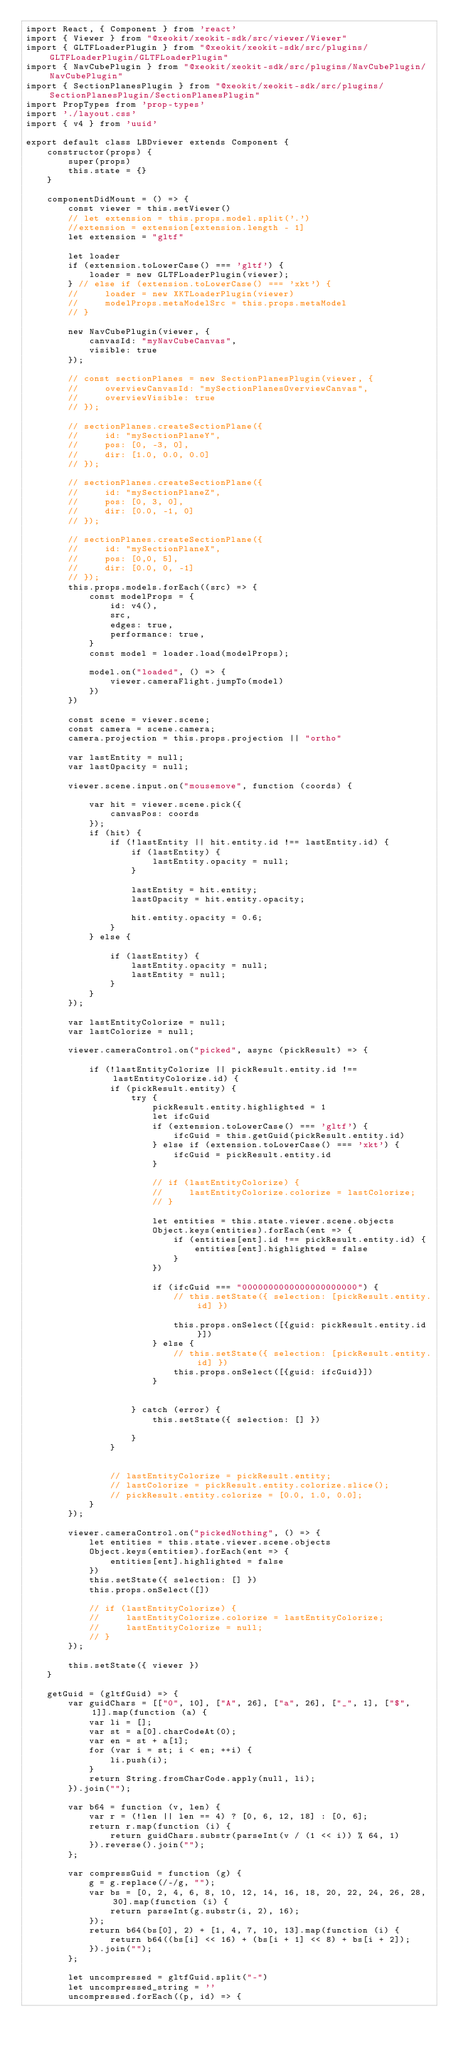<code> <loc_0><loc_0><loc_500><loc_500><_JavaScript_>import React, { Component } from 'react'
import { Viewer } from "@xeokit/xeokit-sdk/src/viewer/Viewer"
import { GLTFLoaderPlugin } from "@xeokit/xeokit-sdk/src/plugins/GLTFLoaderPlugin/GLTFLoaderPlugin"
import { NavCubePlugin } from "@xeokit/xeokit-sdk/src/plugins/NavCubePlugin/NavCubePlugin"
import { SectionPlanesPlugin } from "@xeokit/xeokit-sdk/src/plugins/SectionPlanesPlugin/SectionPlanesPlugin"
import PropTypes from 'prop-types'
import './layout.css'
import { v4 } from 'uuid'

export default class LBDviewer extends Component {
    constructor(props) {
        super(props)
        this.state = {}
    }

    componentDidMount = () => {
        const viewer = this.setViewer()
        // let extension = this.props.model.split('.')
        //extension = extension[extension.length - 1]
        let extension = "gltf"

        let loader
        if (extension.toLowerCase() === 'gltf') {
            loader = new GLTFLoaderPlugin(viewer);
        } // else if (extension.toLowerCase() === 'xkt') {
        //     loader = new XKTLoaderPlugin(viewer)
        //     modelProps.metaModelSrc = this.props.metaModel
        // }

        new NavCubePlugin(viewer, {
            canvasId: "myNavCubeCanvas",
            visible: true
        });

        // const sectionPlanes = new SectionPlanesPlugin(viewer, {
        //     overviewCanvasId: "mySectionPlanesOverviewCanvas",
        //     overviewVisible: true
        // });

        // sectionPlanes.createSectionPlane({
        //     id: "mySectionPlaneY",
        //     pos: [0, -3, 0],
        //     dir: [1.0, 0.0, 0.0]
        // });

        // sectionPlanes.createSectionPlane({
        //     id: "mySectionPlaneZ",
        //     pos: [0, 3, 0],
        //     dir: [0.0, -1, 0]
        // });

        // sectionPlanes.createSectionPlane({
        //     id: "mySectionPlaneX",
        //     pos: [0,0, 5],
        //     dir: [0.0, 0, -1]
        // });
        this.props.models.forEach((src) => {
            const modelProps = {
                id: v4(),
                src,
                edges: true,
                performance: true,
            }
            const model = loader.load(modelProps);

            model.on("loaded", () => {
                viewer.cameraFlight.jumpTo(model)
            })
        })

        const scene = viewer.scene;
        const camera = scene.camera;
        camera.projection = this.props.projection || "ortho"

        var lastEntity = null;
        var lastOpacity = null;

        viewer.scene.input.on("mousemove", function (coords) {

            var hit = viewer.scene.pick({
                canvasPos: coords
            });
            if (hit) {
                if (!lastEntity || hit.entity.id !== lastEntity.id) {
                    if (lastEntity) {
                        lastEntity.opacity = null;
                    }

                    lastEntity = hit.entity;
                    lastOpacity = hit.entity.opacity;

                    hit.entity.opacity = 0.6;
                }
            } else {

                if (lastEntity) {
                    lastEntity.opacity = null;
                    lastEntity = null;
                }
            }
        });

        var lastEntityColorize = null;
        var lastColorize = null;

        viewer.cameraControl.on("picked", async (pickResult) => {

            if (!lastEntityColorize || pickResult.entity.id !== lastEntityColorize.id) {
                if (pickResult.entity) {
                    try {
                        pickResult.entity.highlighted = 1
                        let ifcGuid
                        if (extension.toLowerCase() === 'gltf') {
                            ifcGuid = this.getGuid(pickResult.entity.id)
                        } else if (extension.toLowerCase() === 'xkt') {
                            ifcGuid = pickResult.entity.id
                        }

                        // if (lastEntityColorize) {
                        //     lastEntityColorize.colorize = lastColorize;
                        // }

                        let entities = this.state.viewer.scene.objects
                        Object.keys(entities).forEach(ent => {
                            if (entities[ent].id !== pickResult.entity.id) {
                                entities[ent].highlighted = false
                            }
                        })

                        if (ifcGuid === "0000000000000000000000") {
                            // this.setState({ selection: [pickResult.entity.id] })

                            this.props.onSelect([{guid: pickResult.entity.id}])
                        } else {
                            // this.setState({ selection: [pickResult.entity.id] })
                            this.props.onSelect([{guid: ifcGuid}])
                        }


                    } catch (error) {
                        this.setState({ selection: [] })

                    }
                }


                // lastEntityColorize = pickResult.entity;
                // lastColorize = pickResult.entity.colorize.slice();
                // pickResult.entity.colorize = [0.0, 1.0, 0.0];
            }
        });

        viewer.cameraControl.on("pickedNothing", () => {
            let entities = this.state.viewer.scene.objects
            Object.keys(entities).forEach(ent => {
                entities[ent].highlighted = false
            })
            this.setState({ selection: [] })
            this.props.onSelect([])

            // if (lastEntityColorize) {
            //     lastEntityColorize.colorize = lastEntityColorize;
            //     lastEntityColorize = null;
            // }
        });

        this.setState({ viewer })
    }

    getGuid = (gltfGuid) => {
        var guidChars = [["0", 10], ["A", 26], ["a", 26], ["_", 1], ["$", 1]].map(function (a) {
            var li = [];
            var st = a[0].charCodeAt(0);
            var en = st + a[1];
            for (var i = st; i < en; ++i) {
                li.push(i);
            }
            return String.fromCharCode.apply(null, li);
        }).join("");

        var b64 = function (v, len) {
            var r = (!len || len == 4) ? [0, 6, 12, 18] : [0, 6];
            return r.map(function (i) {
                return guidChars.substr(parseInt(v / (1 << i)) % 64, 1)
            }).reverse().join("");
        };

        var compressGuid = function (g) {
            g = g.replace(/-/g, "");
            var bs = [0, 2, 4, 6, 8, 10, 12, 14, 16, 18, 20, 22, 24, 26, 28, 30].map(function (i) {
                return parseInt(g.substr(i, 2), 16);
            });
            return b64(bs[0], 2) + [1, 4, 7, 10, 13].map(function (i) {
                return b64((bs[i] << 16) + (bs[i + 1] << 8) + bs[i + 2]);
            }).join("");
        };

        let uncompressed = gltfGuid.split("-")
        let uncompressed_string = ''
        uncompressed.forEach((p, id) => {</code> 